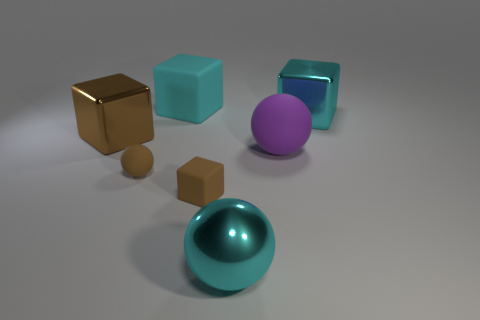Subtract all matte spheres. How many spheres are left? 1 Subtract all gray cylinders. How many brown blocks are left? 2 Add 2 small brown things. How many objects exist? 9 Subtract all spheres. How many objects are left? 4 Subtract 1 cubes. How many cubes are left? 3 Subtract 0 yellow cylinders. How many objects are left? 7 Subtract all gray blocks. Subtract all yellow cylinders. How many blocks are left? 4 Subtract all small cyan cylinders. Subtract all big cyan metallic balls. How many objects are left? 6 Add 3 big blocks. How many big blocks are left? 6 Add 6 rubber cubes. How many rubber cubes exist? 8 